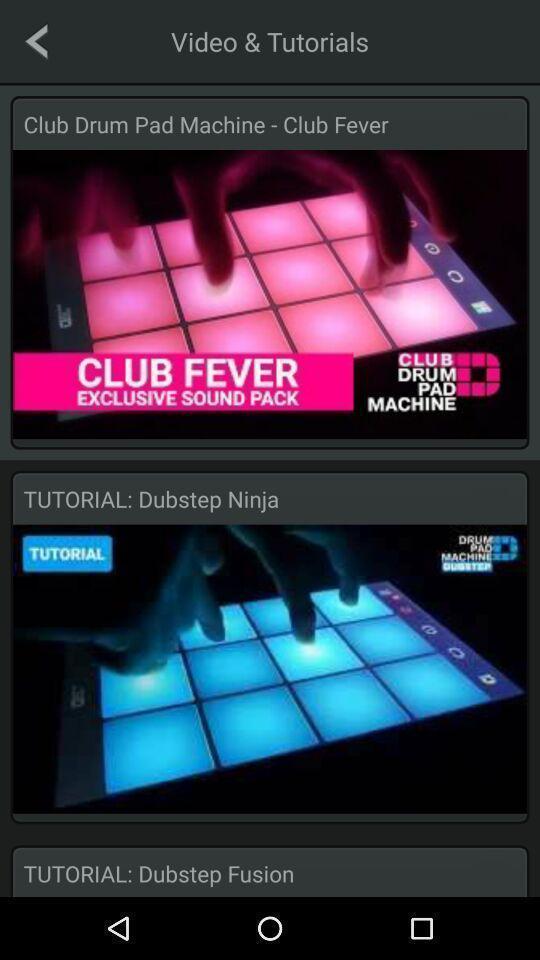Describe this image in words. Page showing the video tutorials. 